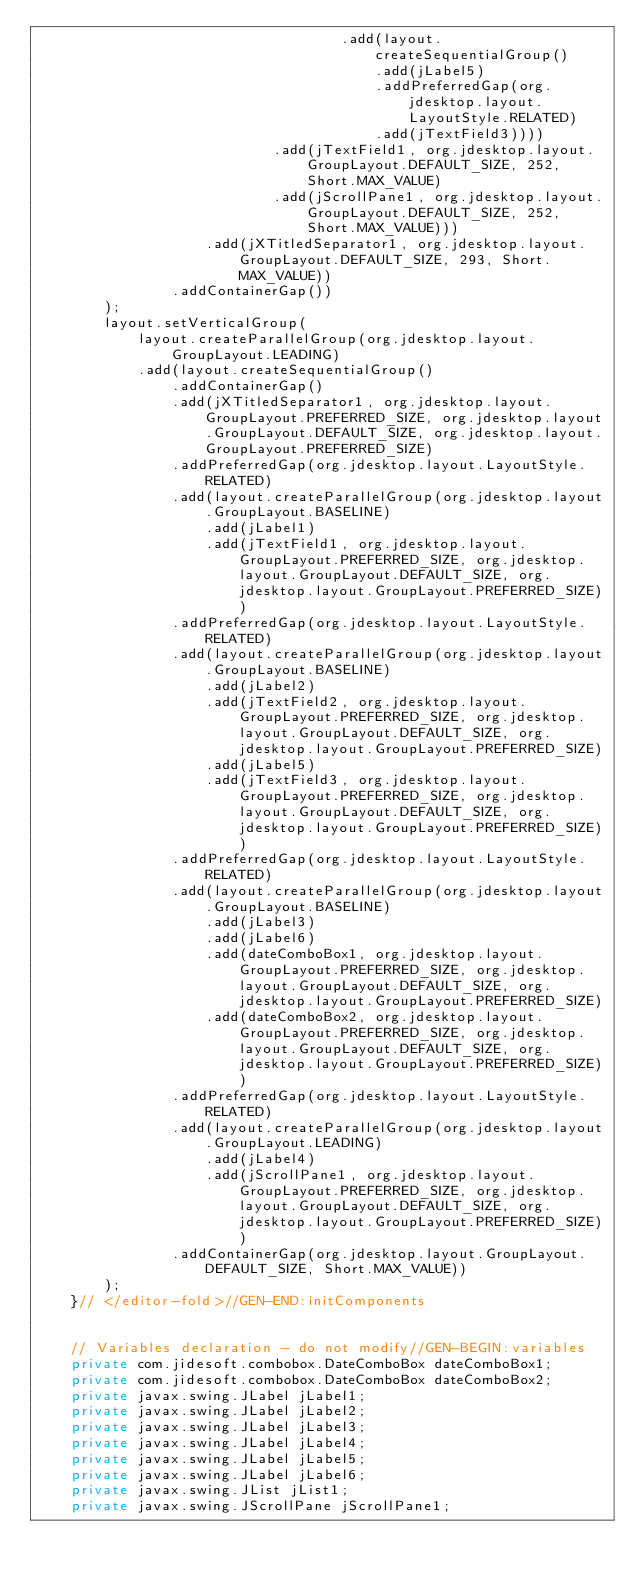<code> <loc_0><loc_0><loc_500><loc_500><_Java_>                                    .add(layout.createSequentialGroup()
                                        .add(jLabel5)
                                        .addPreferredGap(org.jdesktop.layout.LayoutStyle.RELATED)
                                        .add(jTextField3))))
                            .add(jTextField1, org.jdesktop.layout.GroupLayout.DEFAULT_SIZE, 252, Short.MAX_VALUE)
                            .add(jScrollPane1, org.jdesktop.layout.GroupLayout.DEFAULT_SIZE, 252, Short.MAX_VALUE)))
                    .add(jXTitledSeparator1, org.jdesktop.layout.GroupLayout.DEFAULT_SIZE, 293, Short.MAX_VALUE))
                .addContainerGap())
        );
        layout.setVerticalGroup(
            layout.createParallelGroup(org.jdesktop.layout.GroupLayout.LEADING)
            .add(layout.createSequentialGroup()
                .addContainerGap()
                .add(jXTitledSeparator1, org.jdesktop.layout.GroupLayout.PREFERRED_SIZE, org.jdesktop.layout.GroupLayout.DEFAULT_SIZE, org.jdesktop.layout.GroupLayout.PREFERRED_SIZE)
                .addPreferredGap(org.jdesktop.layout.LayoutStyle.RELATED)
                .add(layout.createParallelGroup(org.jdesktop.layout.GroupLayout.BASELINE)
                    .add(jLabel1)
                    .add(jTextField1, org.jdesktop.layout.GroupLayout.PREFERRED_SIZE, org.jdesktop.layout.GroupLayout.DEFAULT_SIZE, org.jdesktop.layout.GroupLayout.PREFERRED_SIZE))
                .addPreferredGap(org.jdesktop.layout.LayoutStyle.RELATED)
                .add(layout.createParallelGroup(org.jdesktop.layout.GroupLayout.BASELINE)
                    .add(jLabel2)
                    .add(jTextField2, org.jdesktop.layout.GroupLayout.PREFERRED_SIZE, org.jdesktop.layout.GroupLayout.DEFAULT_SIZE, org.jdesktop.layout.GroupLayout.PREFERRED_SIZE)
                    .add(jLabel5)
                    .add(jTextField3, org.jdesktop.layout.GroupLayout.PREFERRED_SIZE, org.jdesktop.layout.GroupLayout.DEFAULT_SIZE, org.jdesktop.layout.GroupLayout.PREFERRED_SIZE))
                .addPreferredGap(org.jdesktop.layout.LayoutStyle.RELATED)
                .add(layout.createParallelGroup(org.jdesktop.layout.GroupLayout.BASELINE)
                    .add(jLabel3)
                    .add(jLabel6)
                    .add(dateComboBox1, org.jdesktop.layout.GroupLayout.PREFERRED_SIZE, org.jdesktop.layout.GroupLayout.DEFAULT_SIZE, org.jdesktop.layout.GroupLayout.PREFERRED_SIZE)
                    .add(dateComboBox2, org.jdesktop.layout.GroupLayout.PREFERRED_SIZE, org.jdesktop.layout.GroupLayout.DEFAULT_SIZE, org.jdesktop.layout.GroupLayout.PREFERRED_SIZE))
                .addPreferredGap(org.jdesktop.layout.LayoutStyle.RELATED)
                .add(layout.createParallelGroup(org.jdesktop.layout.GroupLayout.LEADING)
                    .add(jLabel4)
                    .add(jScrollPane1, org.jdesktop.layout.GroupLayout.PREFERRED_SIZE, org.jdesktop.layout.GroupLayout.DEFAULT_SIZE, org.jdesktop.layout.GroupLayout.PREFERRED_SIZE))
                .addContainerGap(org.jdesktop.layout.GroupLayout.DEFAULT_SIZE, Short.MAX_VALUE))
        );
    }// </editor-fold>//GEN-END:initComponents


    // Variables declaration - do not modify//GEN-BEGIN:variables
    private com.jidesoft.combobox.DateComboBox dateComboBox1;
    private com.jidesoft.combobox.DateComboBox dateComboBox2;
    private javax.swing.JLabel jLabel1;
    private javax.swing.JLabel jLabel2;
    private javax.swing.JLabel jLabel3;
    private javax.swing.JLabel jLabel4;
    private javax.swing.JLabel jLabel5;
    private javax.swing.JLabel jLabel6;
    private javax.swing.JList jList1;
    private javax.swing.JScrollPane jScrollPane1;</code> 